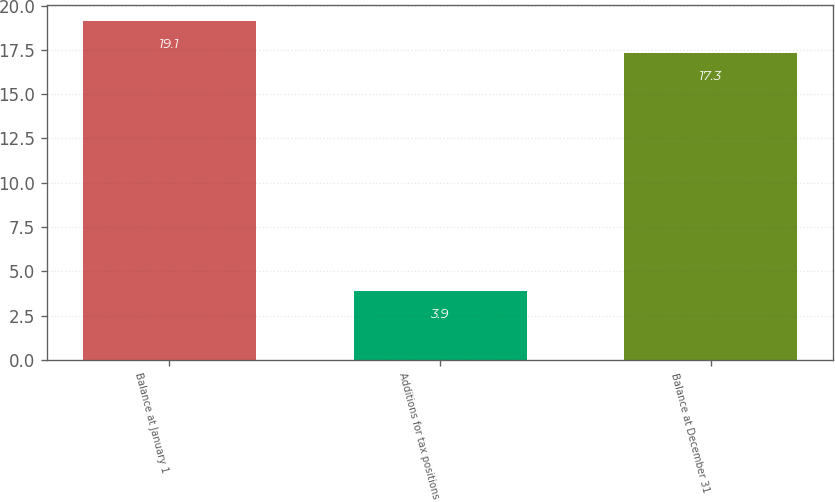Convert chart to OTSL. <chart><loc_0><loc_0><loc_500><loc_500><bar_chart><fcel>Balance at January 1<fcel>Additions for tax positions<fcel>Balance at December 31<nl><fcel>19.1<fcel>3.9<fcel>17.3<nl></chart> 